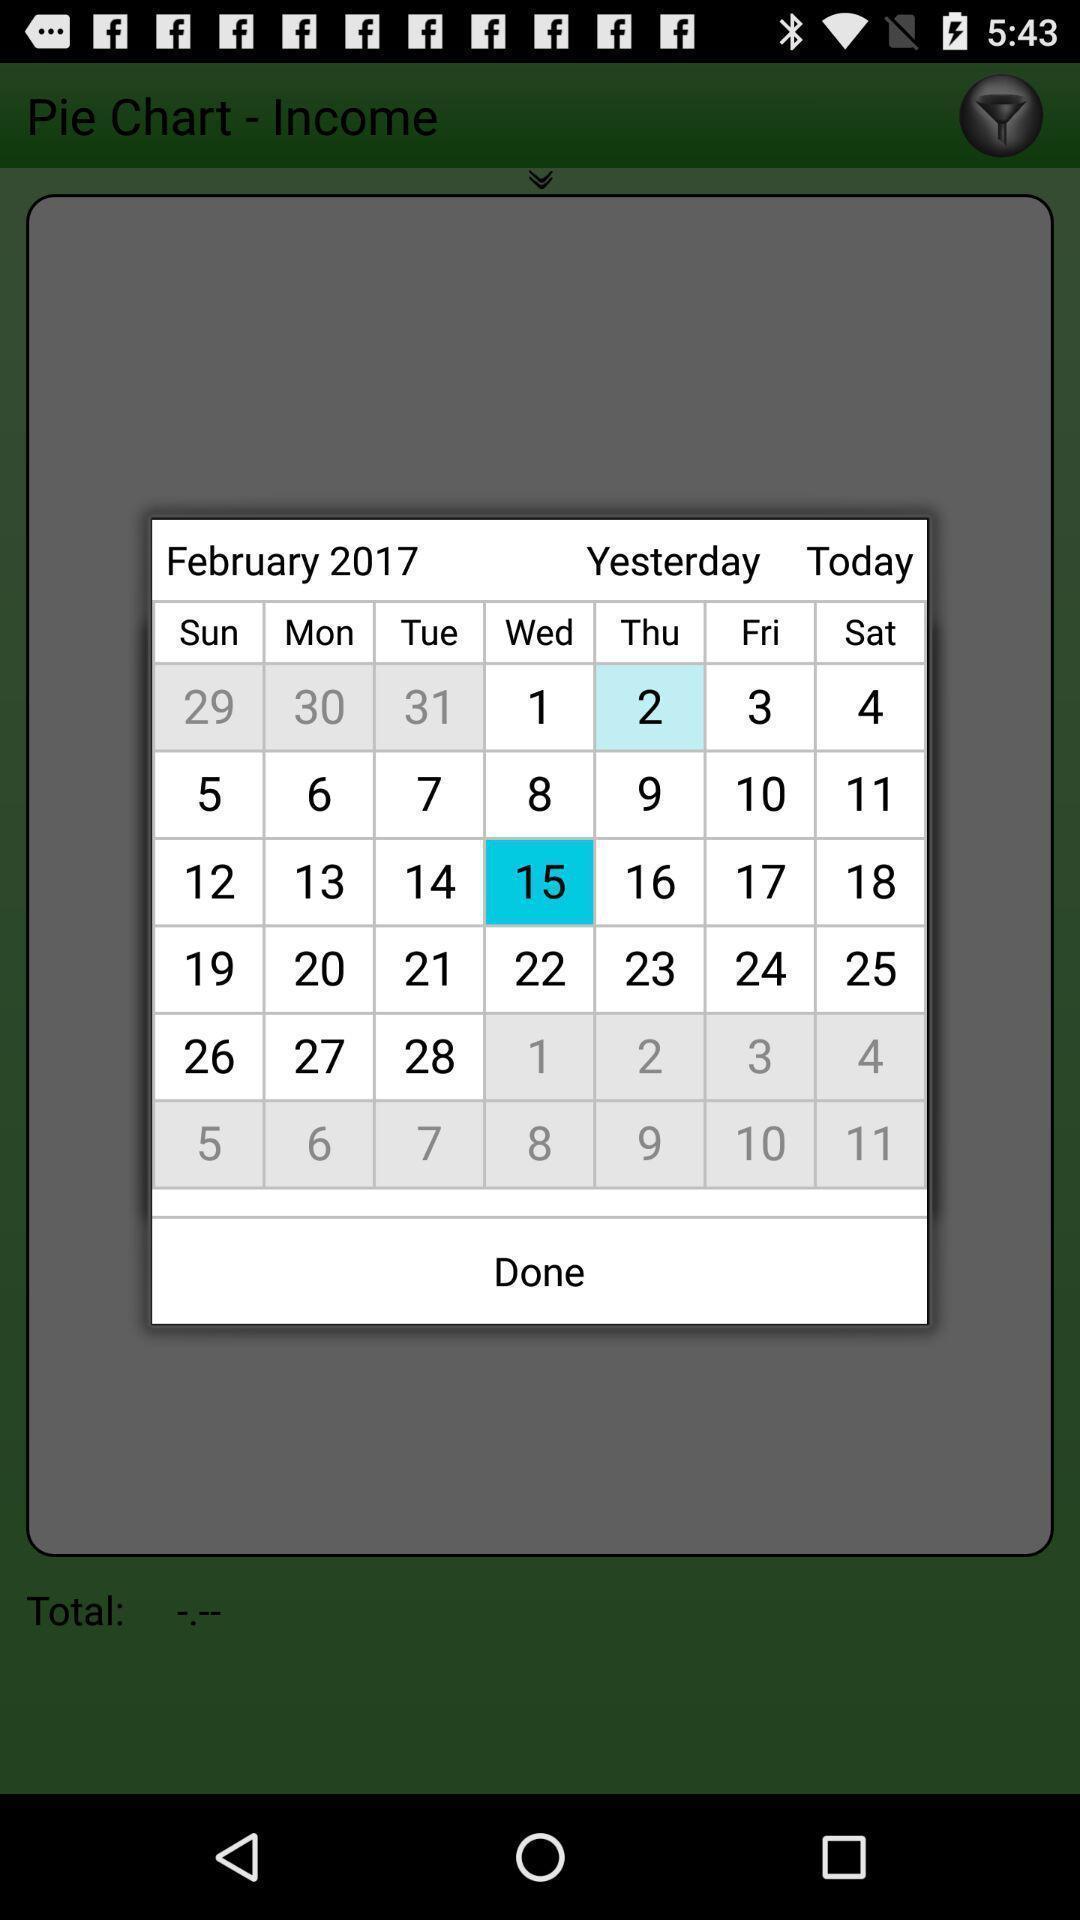Describe the key features of this screenshot. Pop-up showing the month in a calender. 